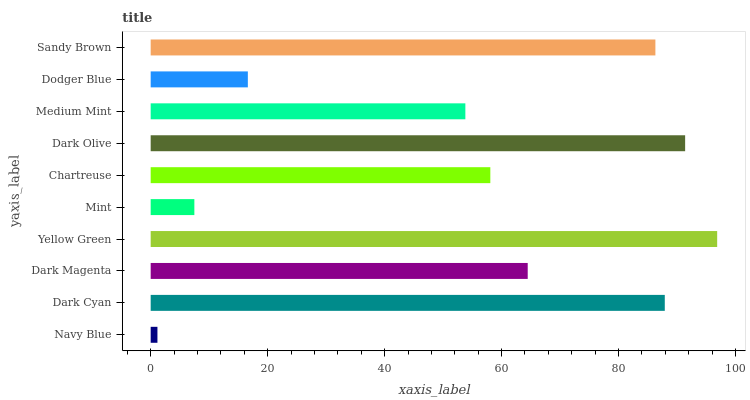Is Navy Blue the minimum?
Answer yes or no. Yes. Is Yellow Green the maximum?
Answer yes or no. Yes. Is Dark Cyan the minimum?
Answer yes or no. No. Is Dark Cyan the maximum?
Answer yes or no. No. Is Dark Cyan greater than Navy Blue?
Answer yes or no. Yes. Is Navy Blue less than Dark Cyan?
Answer yes or no. Yes. Is Navy Blue greater than Dark Cyan?
Answer yes or no. No. Is Dark Cyan less than Navy Blue?
Answer yes or no. No. Is Dark Magenta the high median?
Answer yes or no. Yes. Is Chartreuse the low median?
Answer yes or no. Yes. Is Dark Cyan the high median?
Answer yes or no. No. Is Dark Cyan the low median?
Answer yes or no. No. 